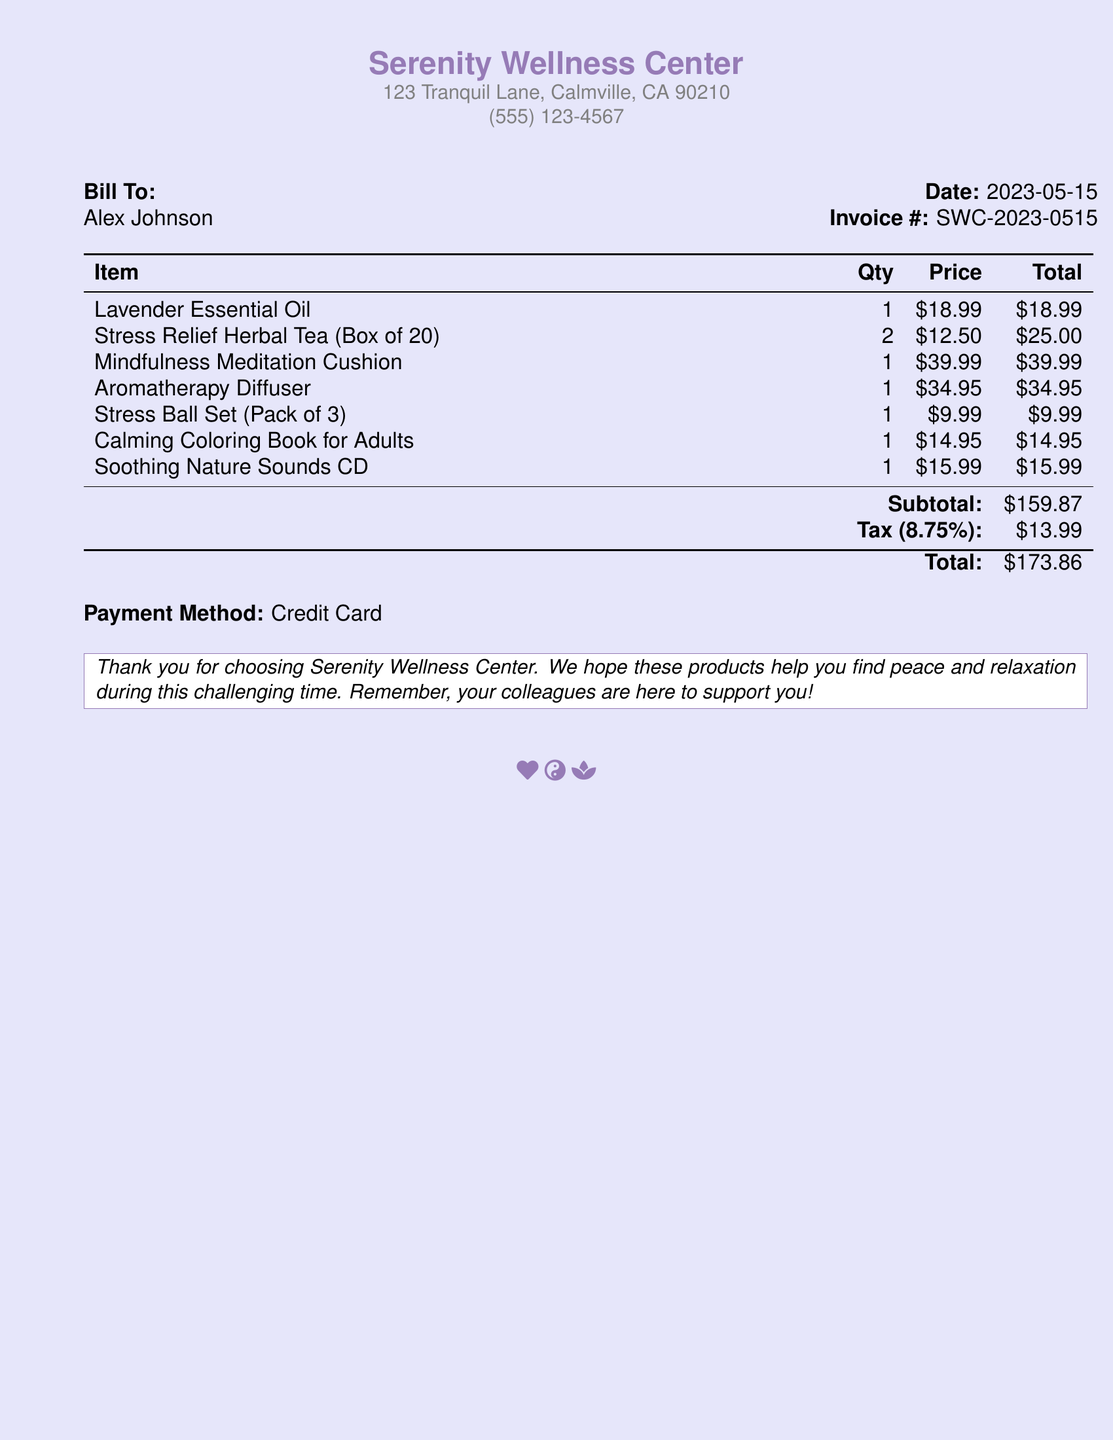What is the name of the wellness center? The name of the wellness center is indicated at the top of the document.
Answer: Serenity Wellness Center Who is the bill addressed to? The recipient's name is mentioned in the 'Bill To' section of the document.
Answer: Alex Johnson What is the date of the invoice? The date can be found in the top right corner of the document.
Answer: 2023-05-15 How many items are listed on the invoice? The number of items can be counted from the itemized table in the document.
Answer: 7 What is the subtotal amount? The subtotal is listed in the table just before the tax calculation.
Answer: $159.87 What is the tax rate applied to the invoice? The tax rate is mentioned in the section detailing the tax calculation.
Answer: 8.75% What is the total amount due? The total amount appears at the bottom of the invoice, after tax calculations.
Answer: $173.86 What payment method was used? The payment method is specified towards the end of the document.
Answer: Credit Card What message is included at the bottom of the invoice? The message is contained in a box at the end of the document, expressing gratitude and support.
Answer: Thank you for choosing Serenity Wellness Center. We hope these products help you find peace and relaxation during this challenging time. Remember, your colleagues are here to support you! 